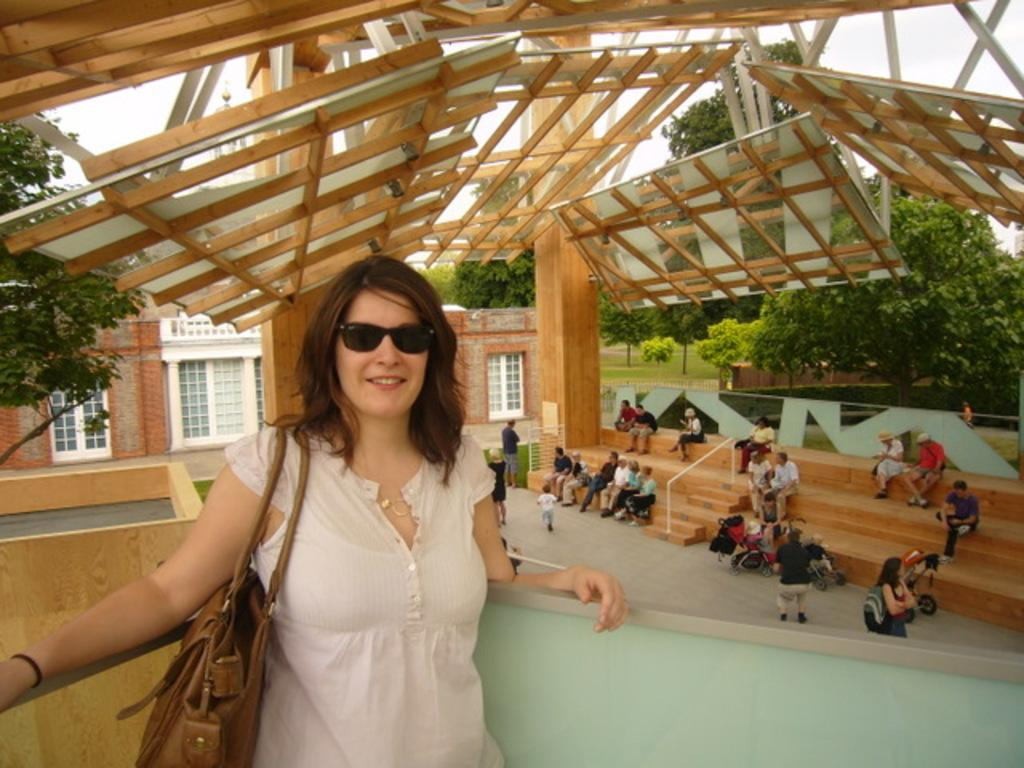Who or what is present in the image? There are people in the image. What architectural feature can be seen in the image? There are stairs in the image. What type of structures are visible in the image? There are buildings in the image. What can be seen on the buildings in the image? There are windows in the image. What type of vegetation is present in the image? There are trees and grass in the image. What is visible at the top of the image? The sky is visible at the top of the image. What type of lip can be seen on the scissors in the image? There are no scissors or lips present in the image. What offer is being made by the people in the image? There is no offer being made by the people in the image; we cannot determine their intentions or actions based on the provided facts. 